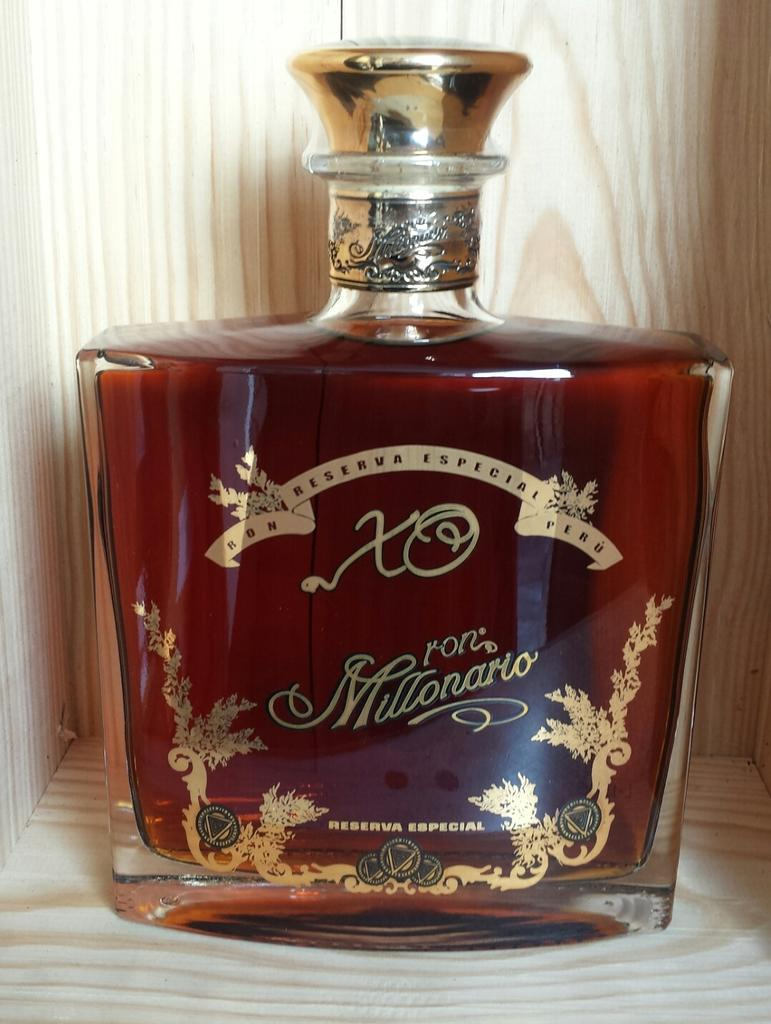<image>
Summarize the visual content of the image. A brown bottle of millionario branded perfume sitting in a wooden box. 